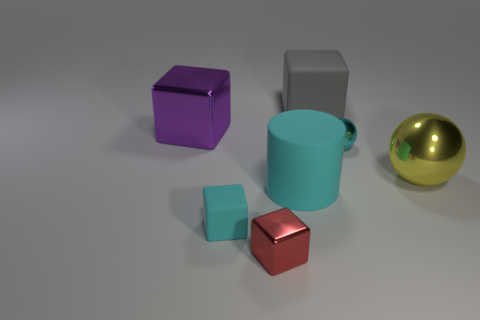Do the cylinder and the tiny matte object have the same color?
Offer a terse response. Yes. How many other things are there of the same color as the large matte cylinder?
Ensure brevity in your answer.  2. The tiny cyan thing to the left of the small metal object left of the tiny cyan metal sphere is what shape?
Your response must be concise. Cube. How many metallic spheres are in front of the cyan shiny ball?
Your response must be concise. 1. Are there any large brown cubes made of the same material as the tiny ball?
Provide a succinct answer. No. There is a yellow object that is the same size as the purple shiny object; what is it made of?
Your response must be concise. Metal. What is the size of the metallic thing that is behind the yellow metallic sphere and left of the small cyan ball?
Make the answer very short. Large. There is a block that is both in front of the purple cube and right of the tiny cyan matte cube; what color is it?
Ensure brevity in your answer.  Red. Are there fewer cyan things that are behind the cyan matte cylinder than shiny spheres to the right of the tiny rubber object?
Ensure brevity in your answer.  Yes. How many other big metal objects have the same shape as the large yellow metallic thing?
Your response must be concise. 0. 